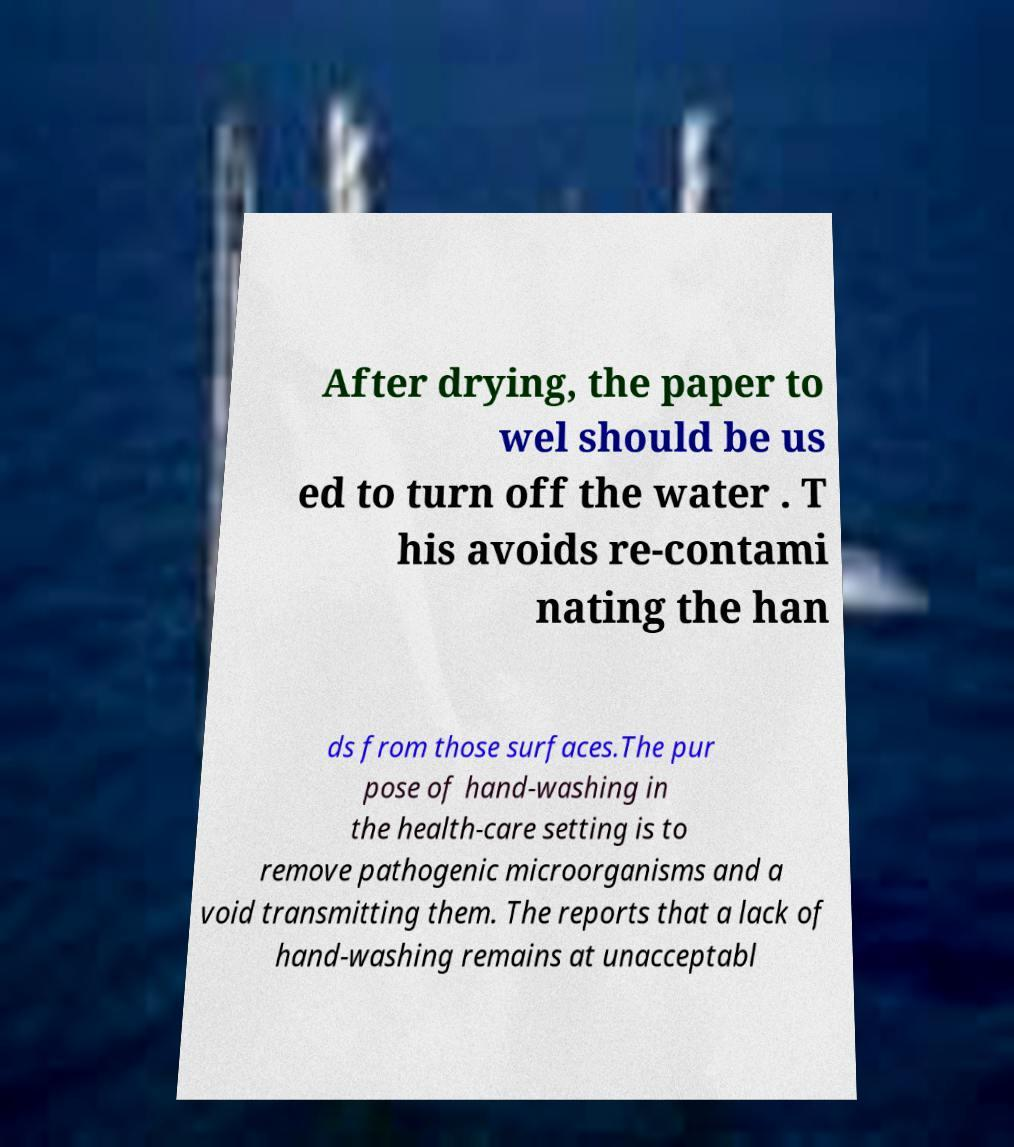For documentation purposes, I need the text within this image transcribed. Could you provide that? After drying, the paper to wel should be us ed to turn off the water . T his avoids re-contami nating the han ds from those surfaces.The pur pose of hand-washing in the health-care setting is to remove pathogenic microorganisms and a void transmitting them. The reports that a lack of hand-washing remains at unacceptabl 